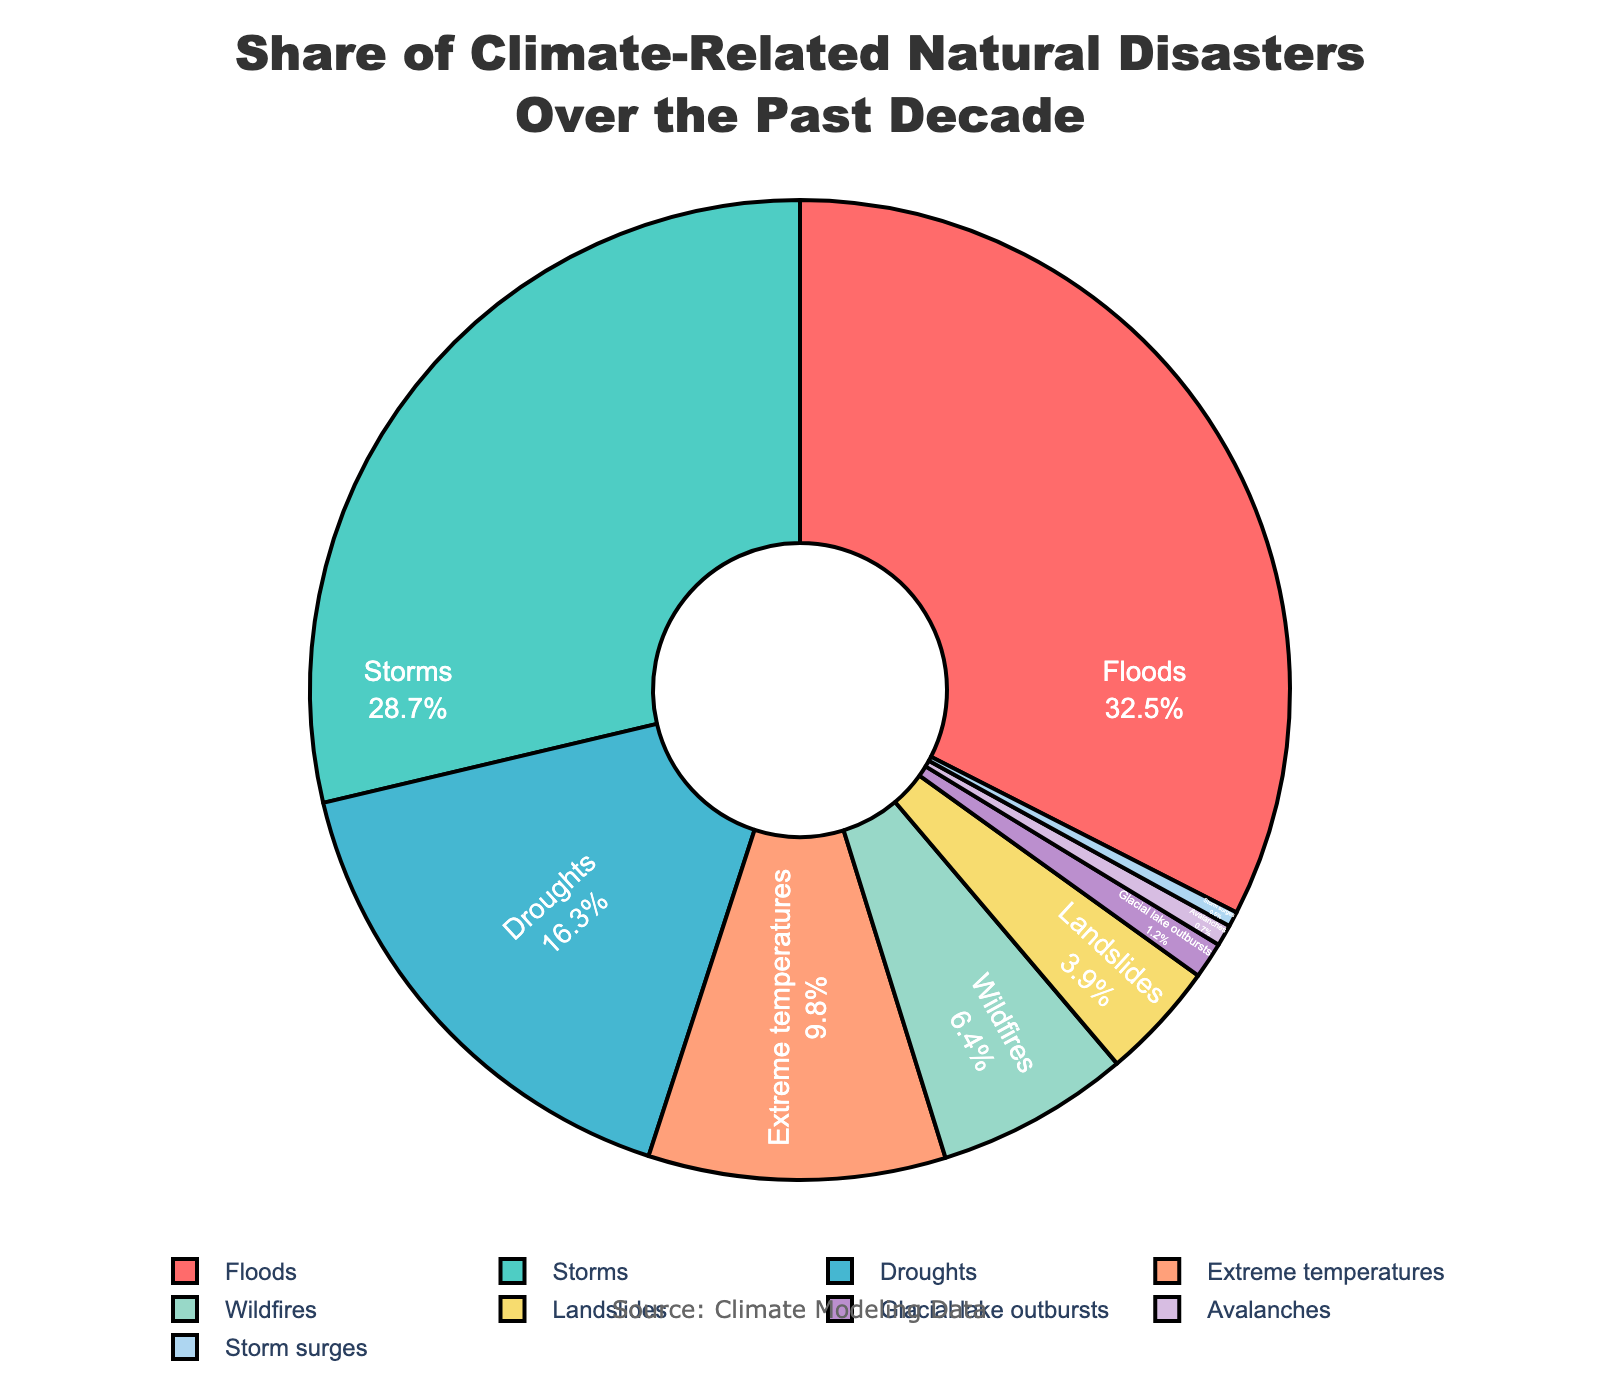what is the most common type of climate-related natural disaster? The segment with the largest percentage of the pie chart represents the most common type. From the figure, Floods are the most significant with 32.5%.
Answer: Floods Which disaster type accounts for more share, wildfires or landslides? Compare the percentages of wildfires (6.4%) and landslides (3.9%) visually. Wildfires have a larger share.
Answer: Wildfires What is the combined percentage of extreme temperatures and avalanches? Add the percentages of extreme temperatures (9.8%) and avalanches (0.7%) to get the combined share. 9.8% + 0.7% = 10.5%.
Answer: 10.5% Which disaster type has the smallest share, and what is that share? The smallest segment in the pie chart represents the type with the smallest share. This is Storm surges with a share of 0.5%.
Answer: Storm surges, 0.5% Is the share of storms greater than the combined share of droughts and wildfires? Sum the percentages of droughts (16.3%) and wildfires (6.4%) which is 22.7%. Compare it with the percentage of storms (28.7%). Since 28.7% > 22.7%, the share of storms is greater.
Answer: Yes What type of disasters together cover more than 50% of all climate-related natural disasters? Identify the shares from the largest until their sum exceeds 50%. Floods (32.5%) and storms (28.7%) together make up 61.2%, which is more than 50%.
Answer: Floods and storms How many types of disasters have a share of less than 5%? From the chart, observe the segments with shares lower than 5%: Landslides (3.9%), Glacial lake outbursts (1.2%), Avalanches (0.7%), and Storm surges (0.5%). There are 4 types.
Answer: 4 What is the difference in share between the most common and the second most common disaster type? Subtract the percentage of storms (the second most common at 28.7%) from floods (the most common at 32.5%). The difference is 32.5% - 28.7% = 3.8%.
Answer: 3.8% Which disaster shares more percentage, droughts or extreme temperatures, and by how much? Compare the percentages of droughts (16.3%) and extreme temperatures (9.8%). The difference is 16.3% - 9.8% = 6.5%.
Answer: Droughts, 6.5% What is the second least common type of climate-related natural disaster, and what is its share? Identify the smallest and then the next smallest segment in the pie chart. The smallest is Storm surges (0.5%) followed by Avalanches (0.7%).
Answer: Avalanches, 0.7% 